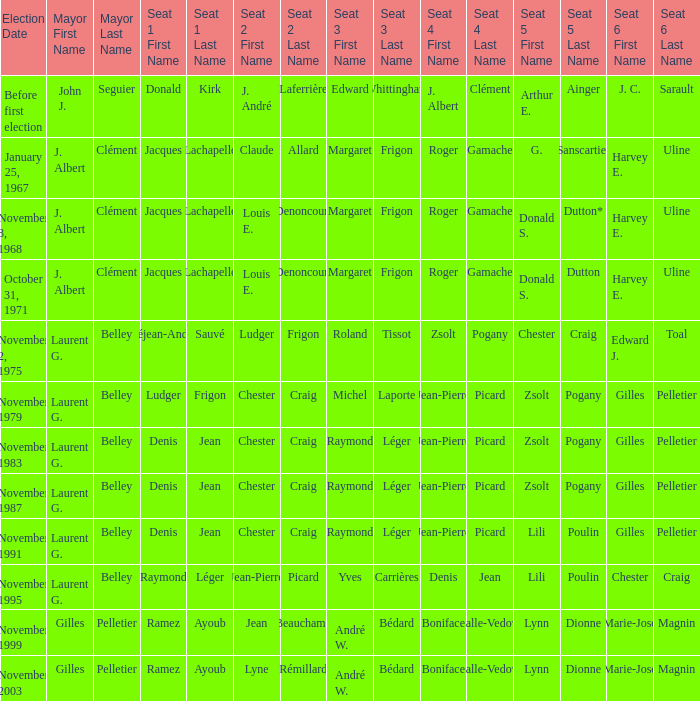Who was the winner of seat no 4 for the election on January 25, 1967 Roger Gamache. 